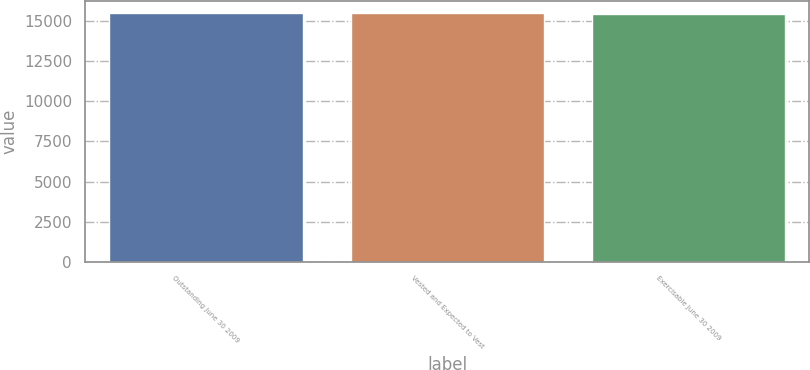Convert chart to OTSL. <chart><loc_0><loc_0><loc_500><loc_500><bar_chart><fcel>Outstanding June 30 2009<fcel>Vested and Expected to Vest<fcel>Exercisable June 30 2009<nl><fcel>15468<fcel>15472.7<fcel>15421<nl></chart> 